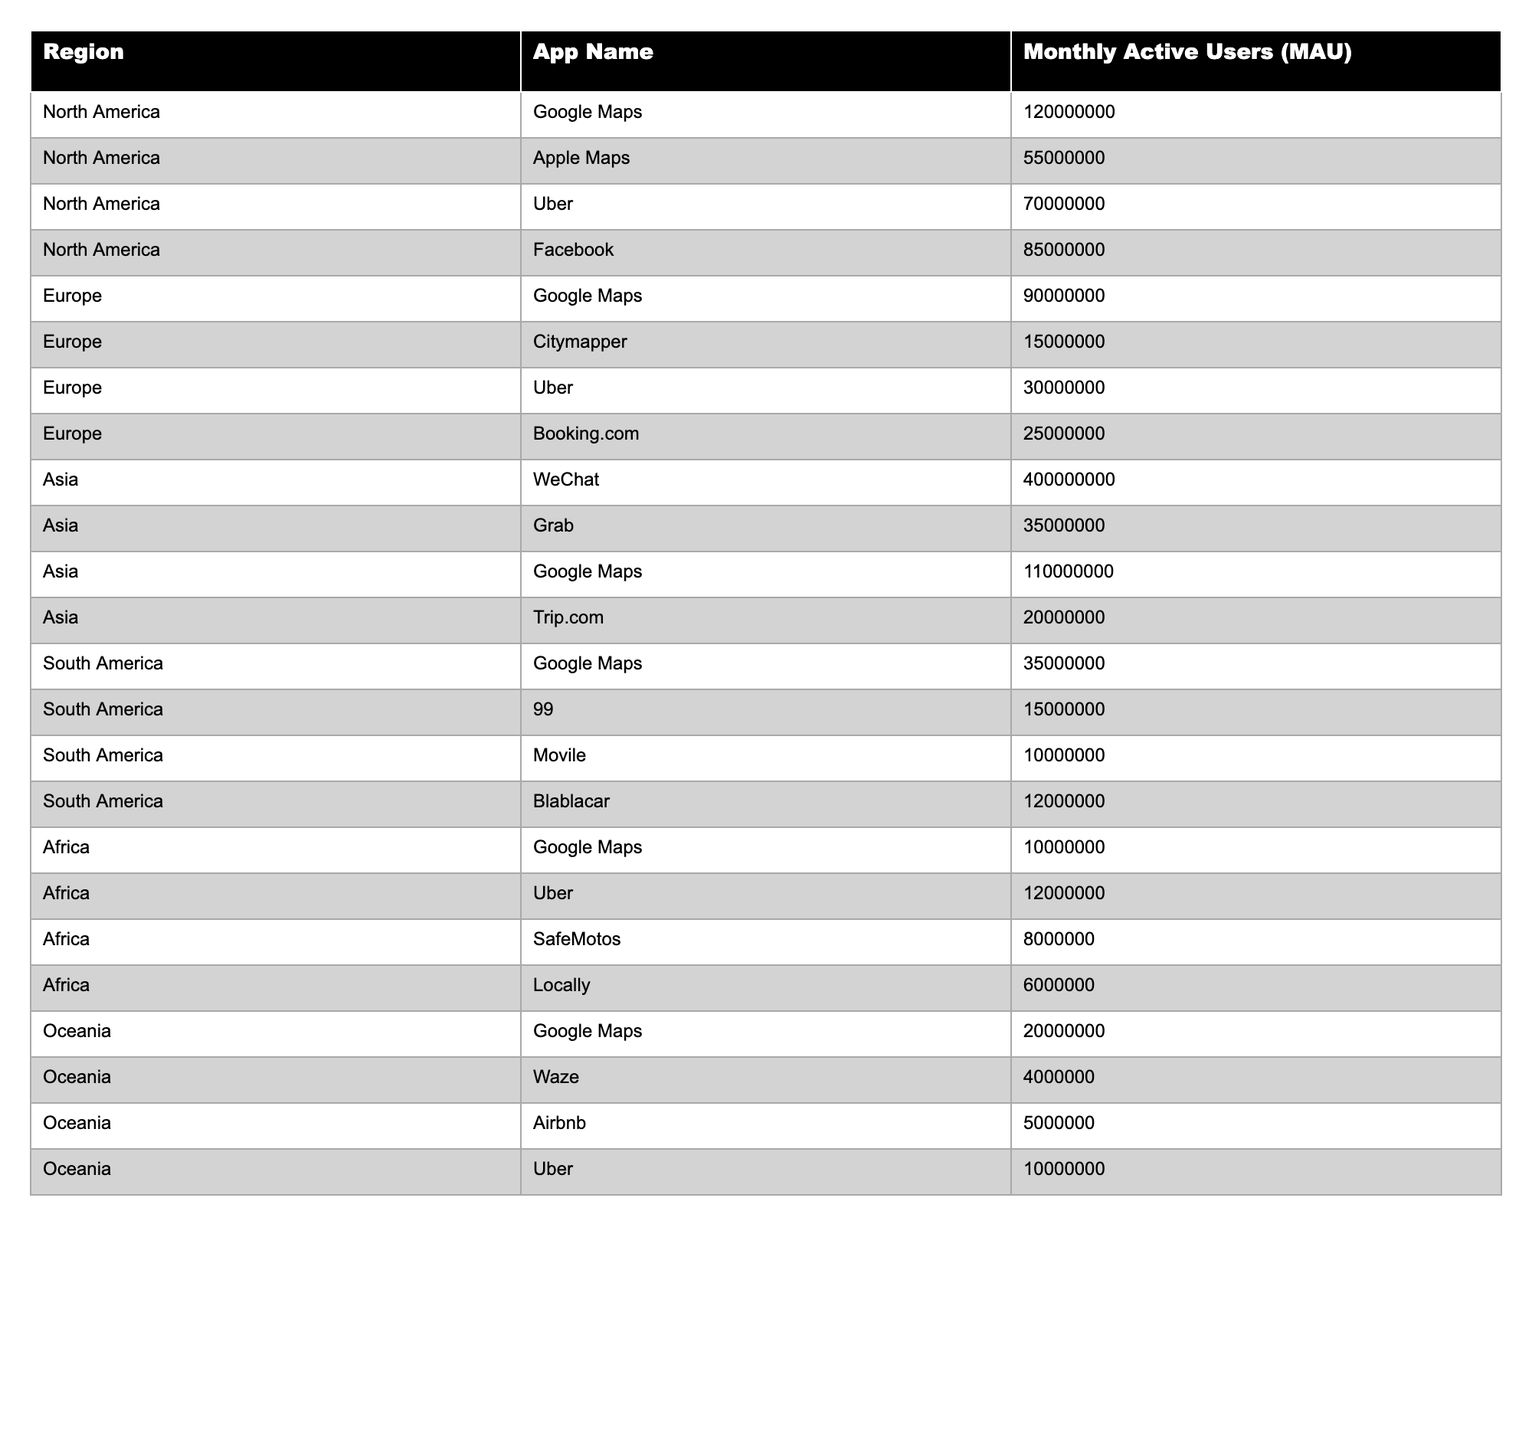What is the total number of Monthly Active Users (MAU) for Google Maps across all regions? In the table, we find the MAU for Google Maps in each region: North America (120,000,000), Europe (90,000,000), Asia (110,000,000), South America (35,000,000), and Africa (10,000,000). Adding these values (120 + 90 + 110 + 35 + 10) gives us a total of 365,000,000.
Answer: 365,000,000 Which region has the highest Monthly Active Users (MAU) for location-based apps? Looking at the table, we see the MAU values for each region: North America has a total of 320,000,000, Europe has 105,000,000, Asia has 400,000,000, South America has 37,000,000, and Africa has 38,000,000. Asia has the highest value of 400,000,000.
Answer: Asia What is the MAU for Uber in Europe? In the table, the MAU for Uber in Europe is listed as 30,000,000.
Answer: 30,000,000 Which app has the least MAU in South America? The table indicates the following MAUs for South America: Google Maps (35,000,000), 99 (15,000,000), Movile (10,000,000), and Blablacar (12,000,000). Movile has the lowest MAU at 10,000,000.
Answer: Movile What is the combined MAU for all apps in North America? The MAU for North America includes: Google Maps (120,000,000), Apple Maps (55,000,000), Uber (70,000,000), and Facebook (85,000,000). Adding these values gives us a total of (120 + 55 + 70 + 85) = 330,000,000.
Answer: 330,000,000 Is the MAU for WeChat greater than the combined MAU for Google Maps in North America and Europa? The MAU for WeChat is 400,000,000, while the combined MAU for Google Maps in North America (120,000,000) and Europe (90,000,000) is 210,000,000. Since 400,000,000 is greater than 210,000,000, the statement is true.
Answer: Yes What percentage of the total MAU in Asia corresponds to the users of Grab? Grab has an MAU of 35,000,000 in Asia, and the total MAU in Asia (WeChat: 400,000,000, Grab: 35,000,000, Google Maps: 110,000,000, Trip.com: 20,000,000) equals 565,000,000. The percentage is (35,000,000 / 565,000,000) * 100 = approximately 6.19%.
Answer: 6.19% What is the difference in MAU between Google Maps in Asia and Google Maps in Europe? The MAU for Google Maps in Asia is 110,000,000, while in Europe it is 90,000,000. The difference is computed as 110,000,000 - 90,000,000 = 20,000,000.
Answer: 20,000,000 Which app has more than 100 million MAU in Asia? From the table, WeChat has an MAU of 400,000,000 and Google Maps has 110,000,000. Only WeChat exceeds 100,000,000.
Answer: WeChat How many apps in Africa have an MAU greater than 10,000,000? The table lists the MAUs for apps in Africa as: Google Maps (10,000,000), Uber (12,000,000), SafeMotos (8,000,000), and Locally (6,000,000). Only Uber has an MAU greater than 10,000,000, so there is one app.
Answer: 1 